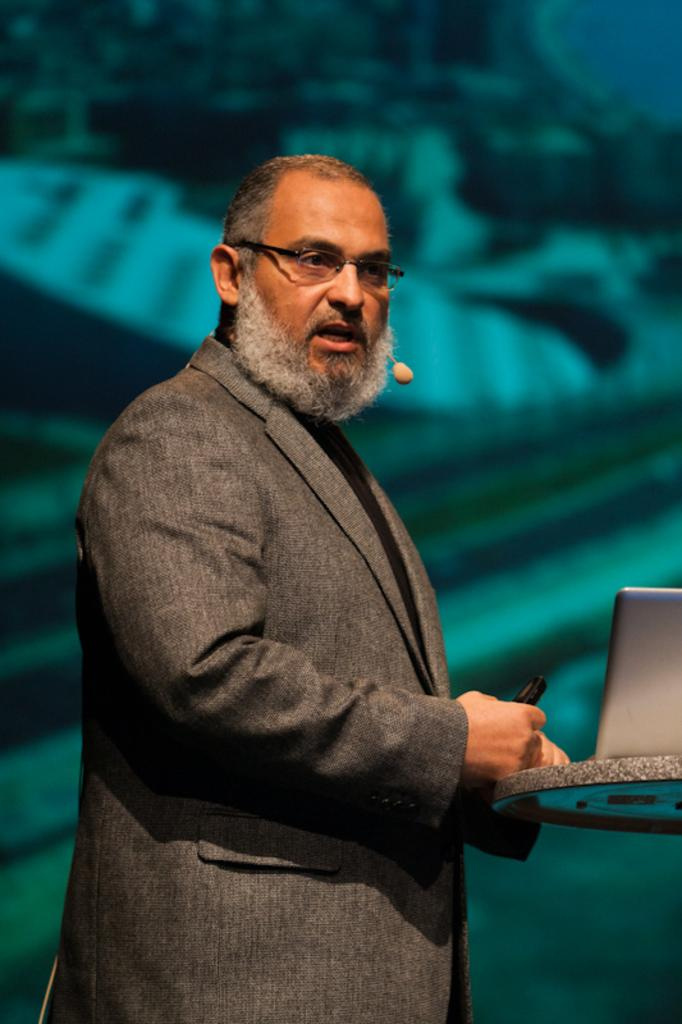What is the main subject of the image? There is a man standing in the image. Can you describe the man's appearance? The man is wearing spectacles and a coat. What is the man holding in his hands? The man is holding something, but the specific object cannot be determined from the image. What electronic device is visible in the image? There is a laptop visible on a surface in the image. What type of fork is the man using to walk in the image? There is no fork or walking depicted in the image; the man is simply standing. 